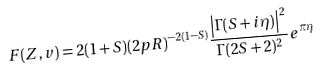<formula> <loc_0><loc_0><loc_500><loc_500>F ( Z , v ) = 2 ( 1 + S ) ( 2 p R ) ^ { - 2 ( 1 - S ) } \frac { \left | \Gamma ( S + i \eta ) \right | ^ { 2 } } { \Gamma ( 2 S + 2 ) ^ { 2 } } e ^ { \pi \eta }</formula> 